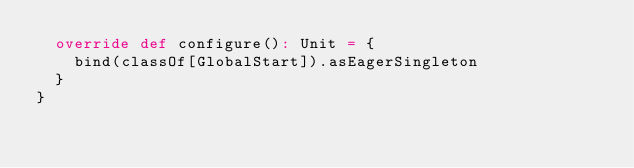Convert code to text. <code><loc_0><loc_0><loc_500><loc_500><_Scala_>  override def configure(): Unit = {
    bind(classOf[GlobalStart]).asEagerSingleton
  }
}
</code> 